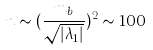Convert formula to latex. <formula><loc_0><loc_0><loc_500><loc_500>n \sim ( \frac { m _ { b } } { \sqrt { | \lambda _ { 1 } | } } ) ^ { 2 } \sim 1 0 0</formula> 